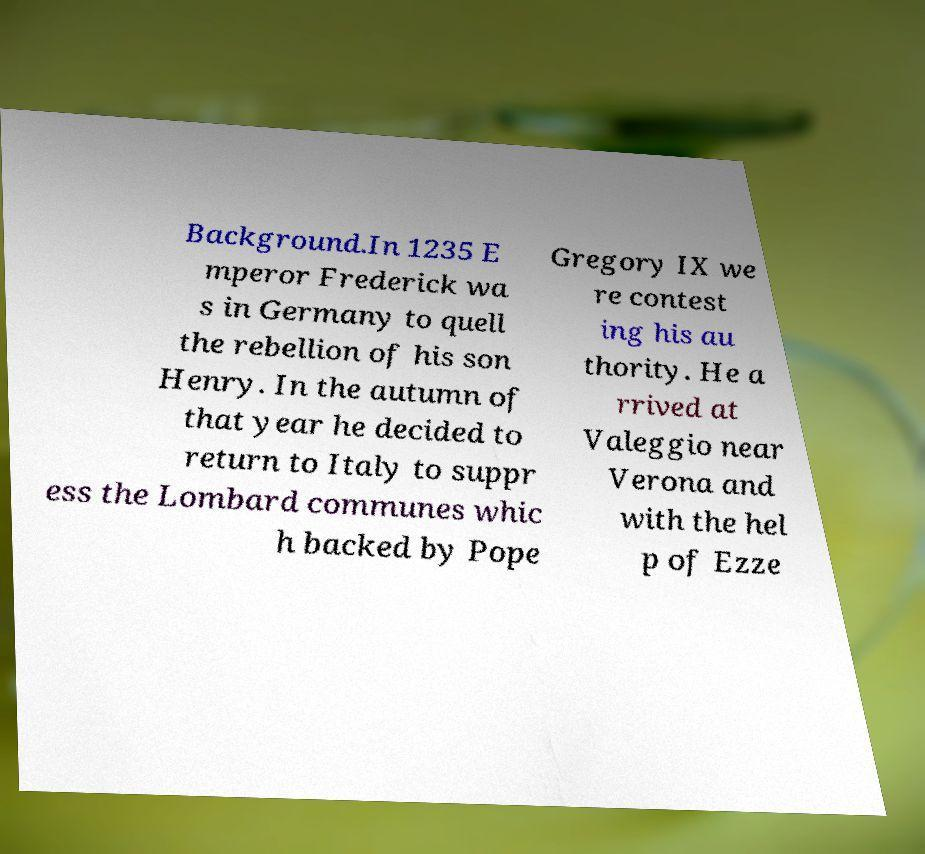What messages or text are displayed in this image? I need them in a readable, typed format. Background.In 1235 E mperor Frederick wa s in Germany to quell the rebellion of his son Henry. In the autumn of that year he decided to return to Italy to suppr ess the Lombard communes whic h backed by Pope Gregory IX we re contest ing his au thority. He a rrived at Valeggio near Verona and with the hel p of Ezze 